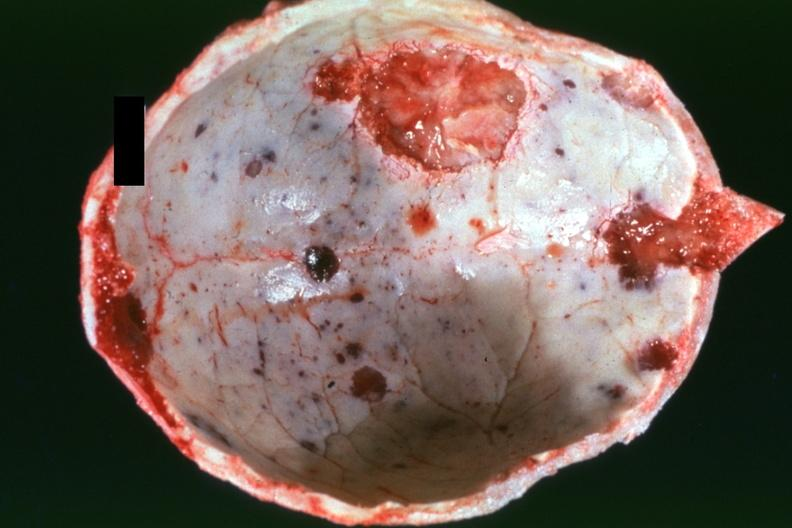does this image show dr garcia tumors b5?
Answer the question using a single word or phrase. Yes 